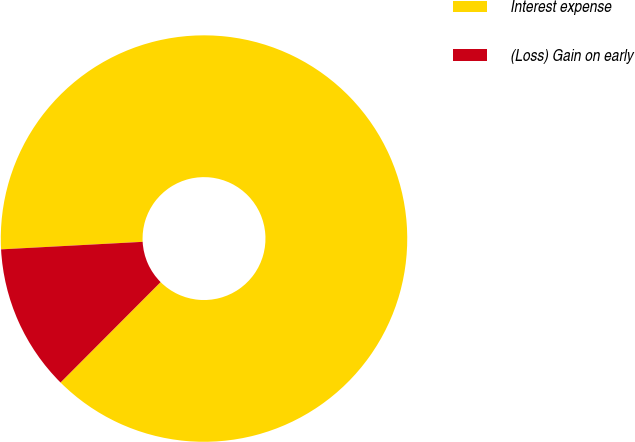<chart> <loc_0><loc_0><loc_500><loc_500><pie_chart><fcel>Interest expense<fcel>(Loss) Gain on early<nl><fcel>88.32%<fcel>11.68%<nl></chart> 